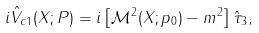<formula> <loc_0><loc_0><loc_500><loc_500>i \hat { V } _ { c 1 } ( X ; P ) = i \left [ \mathcal { M } ^ { 2 } ( X ; p _ { 0 } ) - m ^ { 2 } \right ] \hat { \tau } _ { 3 } ,</formula> 